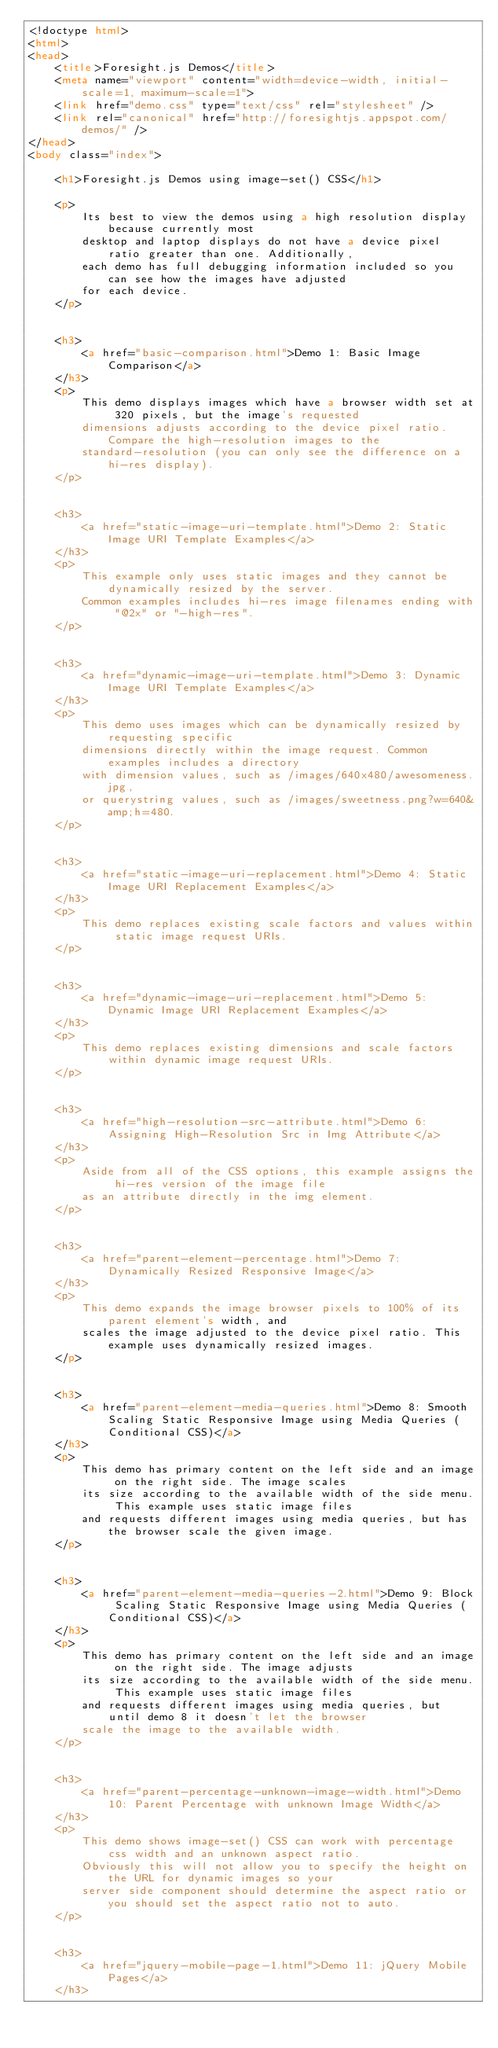<code> <loc_0><loc_0><loc_500><loc_500><_HTML_><!doctype html>
<html>
<head>
	<title>Foresight.js Demos</title>
	<meta name="viewport" content="width=device-width, initial-scale=1, maximum-scale=1">
	<link href="demo.css" type="text/css" rel="stylesheet" />
	<link rel="canonical" href="http://foresightjs.appspot.com/demos/" />
</head>
<body class="index">

	<h1>Foresight.js Demos using image-set() CSS</h1>

	<p>
		Its best to view the demos using a high resolution display because currently most 
		desktop and laptop displays do not have a device pixel ratio greater than one. Additionally,
		each demo has full debugging information included so you can see how the images have adjusted
		for each device.
	</p>


	<h3>
		<a href="basic-comparison.html">Demo 1: Basic Image Comparison</a>
	</h3>
	<p>
		This demo displays images which have a browser width set at 320 pixels, but the image's requested
		dimensions adjusts according to the device pixel ratio. Compare the high-resolution images to the 
		standard-resolution (you can only see the difference on a hi-res display).
	</p>


	<h3>
		<a href="static-image-uri-template.html">Demo 2: Static Image URI Template Examples</a>
	</h3>
	<p>
		This example only uses static images and they cannot be dynamically resized by the server.
		Common examples includes hi-res image filenames ending with "@2x" or "-high-res".
	</p>


	<h3>
		<a href="dynamic-image-uri-template.html">Demo 3: Dynamic Image URI Template Examples</a>
	</h3>
	<p>
		This demo uses images which can be dynamically resized by requesting specific 
		dimensions directly within the image request. Common examples includes a directory 
		with dimension values, such as /images/640x480/awesomeness.jpg,
		or querystring values, such as /images/sweetness.png?w=640&amp;h=480.
	</p>


	<h3>
		<a href="static-image-uri-replacement.html">Demo 4: Static Image URI Replacement Examples</a>
	</h3>
	<p>
		This demo replaces existing scale factors and values within static image request URIs.
	</p>


	<h3>
		<a href="dynamic-image-uri-replacement.html">Demo 5: Dynamic Image URI Replacement Examples</a>
	</h3>
	<p>
		This demo replaces existing dimensions and scale factors within dynamic image request URIs.
	</p>


	<h3>
		<a href="high-resolution-src-attribute.html">Demo 6: Assigning High-Resolution Src in Img Attribute</a>
	</h3>
	<p>
		Aside from all of the CSS options, this example assigns the hi-res version of the image file
		as an attribute directly in the img element.
	</p>


	<h3>
		<a href="parent-element-percentage.html">Demo 7: Dynamically Resized Responsive Image</a>
	</h3>
	<p>
		This demo expands the image browser pixels to 100% of its parent element's width, and 
		scales the image adjusted to the device pixel ratio. This example uses dynamically resized images.
	</p>


	<h3>
		<a href="parent-element-media-queries.html">Demo 8: Smooth Scaling Static Responsive Image using Media Queries (Conditional CSS)</a>
	</h3>
	<p>
		This demo has primary content on the left side and an image on the right side. The image scales
		its size according to the available width of the side menu. This example uses static image files
		and requests different images using media queries, but has the browser scale the given image.
	</p>


	<h3>
		<a href="parent-element-media-queries-2.html">Demo 9: Block Scaling Static Responsive Image using Media Queries (Conditional CSS)</a>
	</h3>
	<p>
		This demo has primary content on the left side and an image on the right side. The image adjusts
		its size according to the available width of the side menu. This example uses static image files
		and requests different images using media queries, but until demo 8 it doesn't let the browser
		scale the image to the available width.
	</p>


	<h3>
		<a href="parent-percentage-unknown-image-width.html">Demo 10: Parent Percentage with unknown Image Width</a>
	</h3>
	<p>
		This demo shows image-set() CSS can work with percentage css width and an unknown aspect ratio. 
		Obviously this will not allow you to specify the height on the URL for dynamic images so your 
		server side component should determine the aspect ratio or you should set the aspect ratio not to auto.
	</p>


	<h3>
		<a href="jquery-mobile-page-1.html">Demo 11: jQuery Mobile Pages</a>
	</h3></code> 